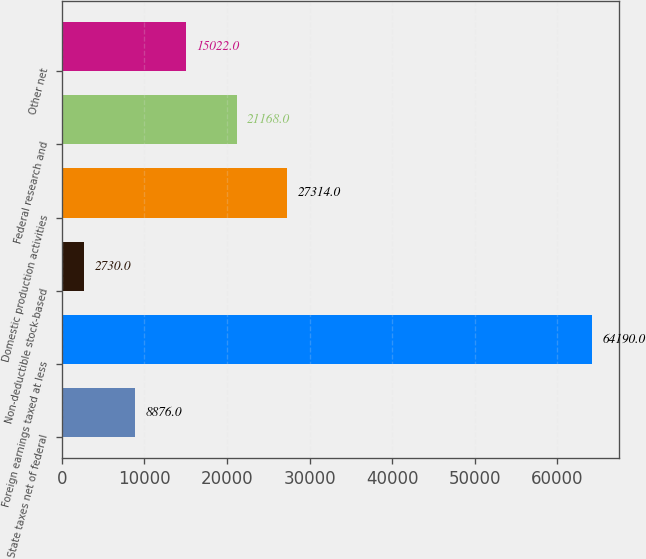Convert chart. <chart><loc_0><loc_0><loc_500><loc_500><bar_chart><fcel>State taxes net of federal<fcel>Foreign earnings taxed at less<fcel>Non-deductible stock-based<fcel>Domestic production activities<fcel>Federal research and<fcel>Other net<nl><fcel>8876<fcel>64190<fcel>2730<fcel>27314<fcel>21168<fcel>15022<nl></chart> 